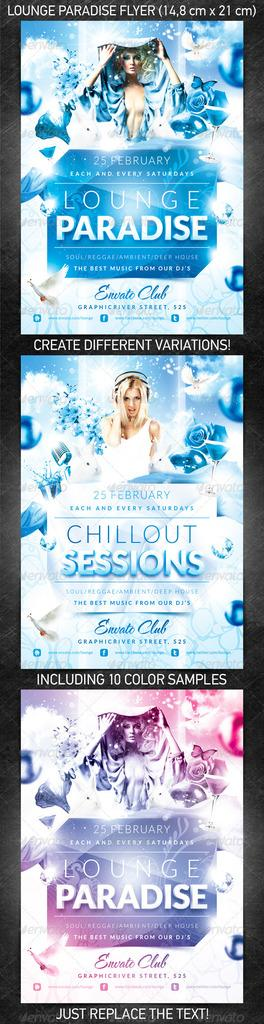<image>
Describe the image concisely. A flyer for a club called "Lounge Paradise." 